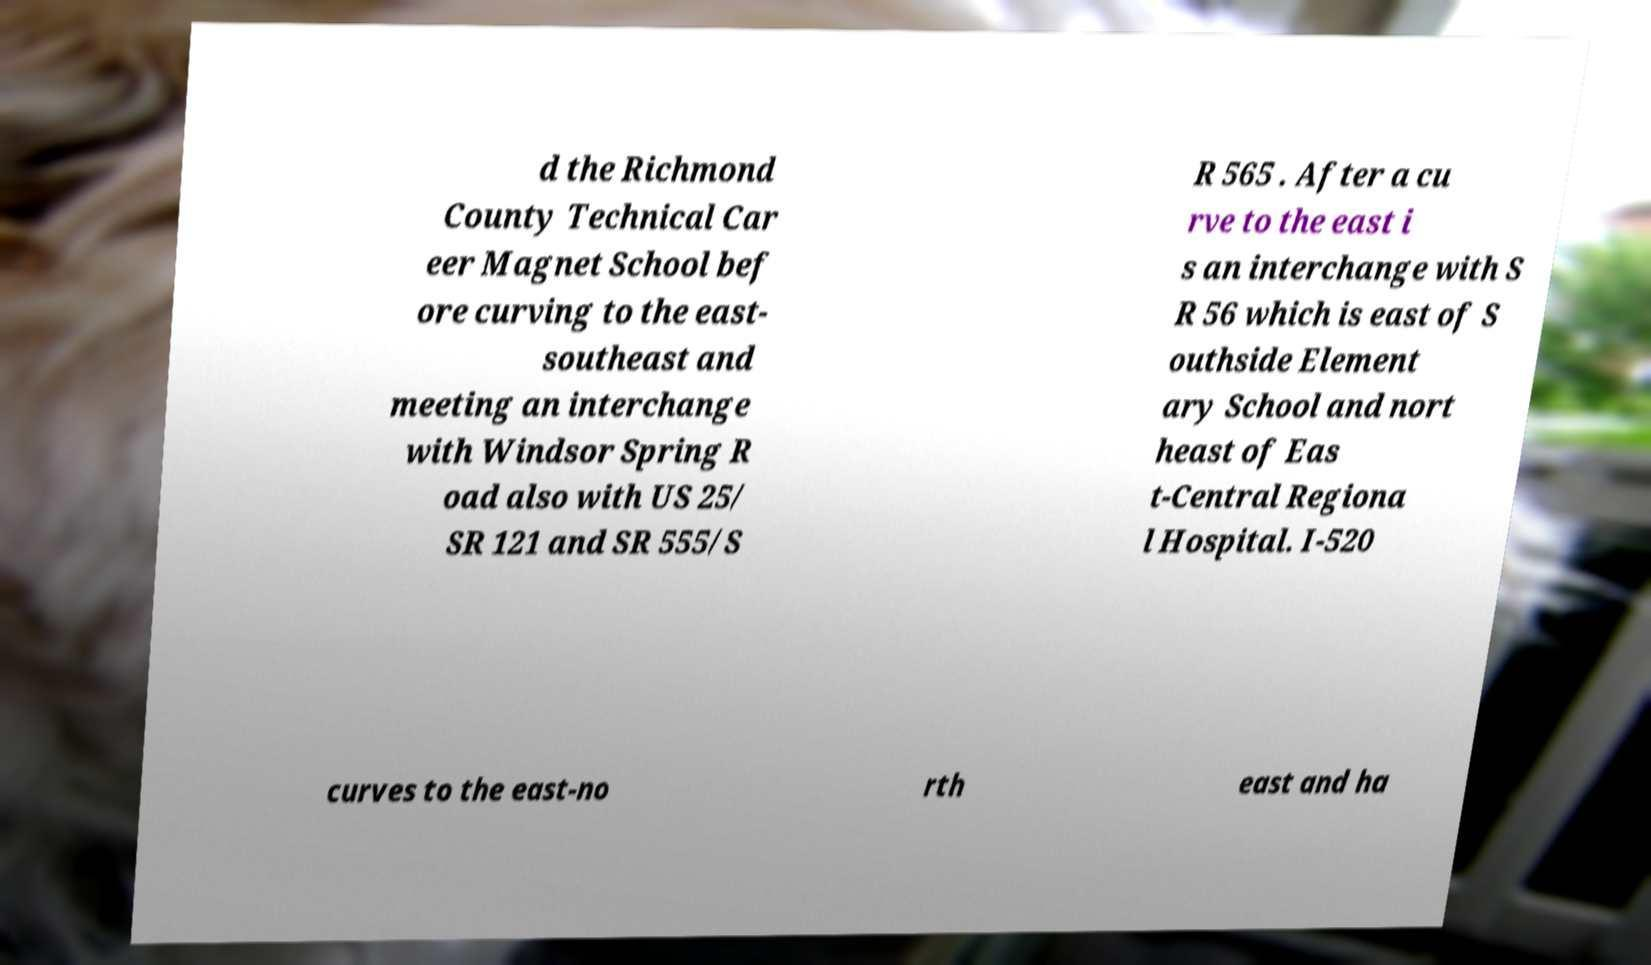Could you assist in decoding the text presented in this image and type it out clearly? d the Richmond County Technical Car eer Magnet School bef ore curving to the east- southeast and meeting an interchange with Windsor Spring R oad also with US 25/ SR 121 and SR 555/S R 565 . After a cu rve to the east i s an interchange with S R 56 which is east of S outhside Element ary School and nort heast of Eas t-Central Regiona l Hospital. I-520 curves to the east-no rth east and ha 